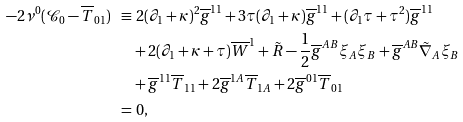<formula> <loc_0><loc_0><loc_500><loc_500>- 2 \nu ^ { 0 } ( \mathcal { C } _ { 0 } - \overline { T } _ { 0 1 } ) \ \equiv & \ 2 ( \partial _ { 1 } + \kappa ) ^ { 2 } \overline { g } ^ { 1 1 } + 3 \tau ( \partial _ { 1 } + \kappa ) \overline { g } ^ { 1 1 } + ( \partial _ { 1 } \tau + \tau ^ { 2 } ) \overline { g } ^ { 1 1 } \\ & + 2 ( \partial _ { 1 } + \kappa + \tau ) \overline { W } ^ { 1 } + \tilde { R } - \frac { 1 } { 2 } \overline { g } ^ { A B } \xi _ { A } \xi _ { B } + \overline { g } ^ { A B } \tilde { \nabla } _ { A } \xi _ { B } \\ & + \overline { g } ^ { 1 1 } \overline { T } _ { 1 1 } + 2 \overline { g } ^ { 1 A } \overline { T } _ { 1 A } + 2 \overline { g } ^ { 0 1 } \overline { T } _ { 0 1 } \\ = & \ 0 ,</formula> 